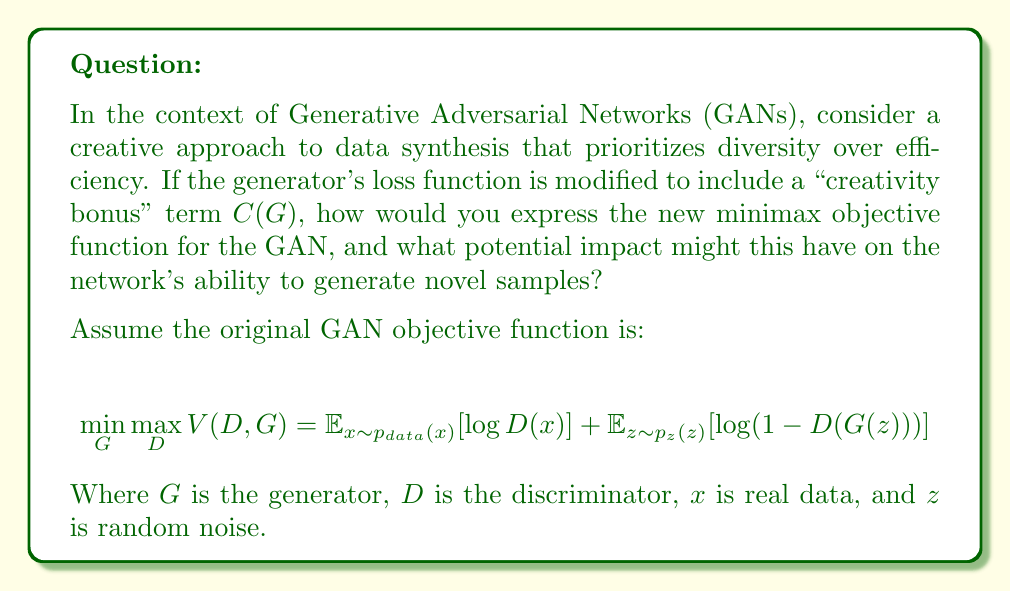What is the answer to this math problem? To address this question, we need to consider how incorporating a creativity bonus might alter the GAN's objective function and its implications. Let's break it down step-by-step:

1) The original GAN objective function aims to find an equilibrium between the generator and discriminator. The generator tries to minimize this function while the discriminator tries to maximize it.

2) To incorporate a creativity bonus, we can add a term $C(G)$ to the objective function that rewards the generator for producing diverse or novel outputs. This term should be maximized by the generator.

3) The new objective function could be expressed as:

   $$\min_G \max_D V(D,G) = \mathbb{E}_{x\sim p_{data}(x)}[\log D(x)] + \mathbb{E}_{z\sim p_z(z)}[\log(1-D(G(z)))] - \lambda C(G)$$

   Where $\lambda$ is a hyperparameter that controls the weight of the creativity bonus.

4) The creativity bonus $C(G)$ could be designed in various ways, depending on how we define creativity. For example, it could be based on the diversity of generated samples, the novelty compared to the training data, or the complexity of the generated outputs.

5) One possible formulation for $C(G)$ could be:

   $$C(G) = -\mathbb{E}_{z_1,z_2\sim p_z(z)}[\text{similarity}(G(z_1), G(z_2))]$$

   This encourages the generator to produce diverse outputs by penalizing similarity between generated samples.

6) The impact of this modification on the GAN's ability to generate novel samples could be significant:
   - It may lead to more diverse and potentially more creative outputs.
   - The generator might explore areas of the data space that are underrepresented in the original dataset.
   - However, it could also potentially lead to less realistic outputs if the creativity bonus is weighted too heavily.

7) The challenge would be to balance the creativity bonus with the original objective of producing realistic samples. This balance is controlled by the $\lambda$ parameter.

This approach aligns with the persona of a data analyst who believes that focusing solely on efficiency can hinder innovation and creativity. By explicitly rewarding creativity in the objective function, we're encouraging the GAN to explore beyond simple replication of the training data.
Answer: The new minimax objective function for the GAN with a creativity bonus is:

$$\min_G \max_D V(D,G) = \mathbb{E}_{x\sim p_{data}(x)}[\log D(x)] + \mathbb{E}_{z\sim p_z(z)}[\log(1-D(G(z)))] - \lambda C(G)$$

Where $C(G)$ is a creativity bonus term and $\lambda$ is a hyperparameter controlling its weight. This modification could potentially lead to more diverse and novel generated samples, encouraging exploration of underrepresented areas in the data space, at the risk of potentially less realistic outputs if not properly balanced. 